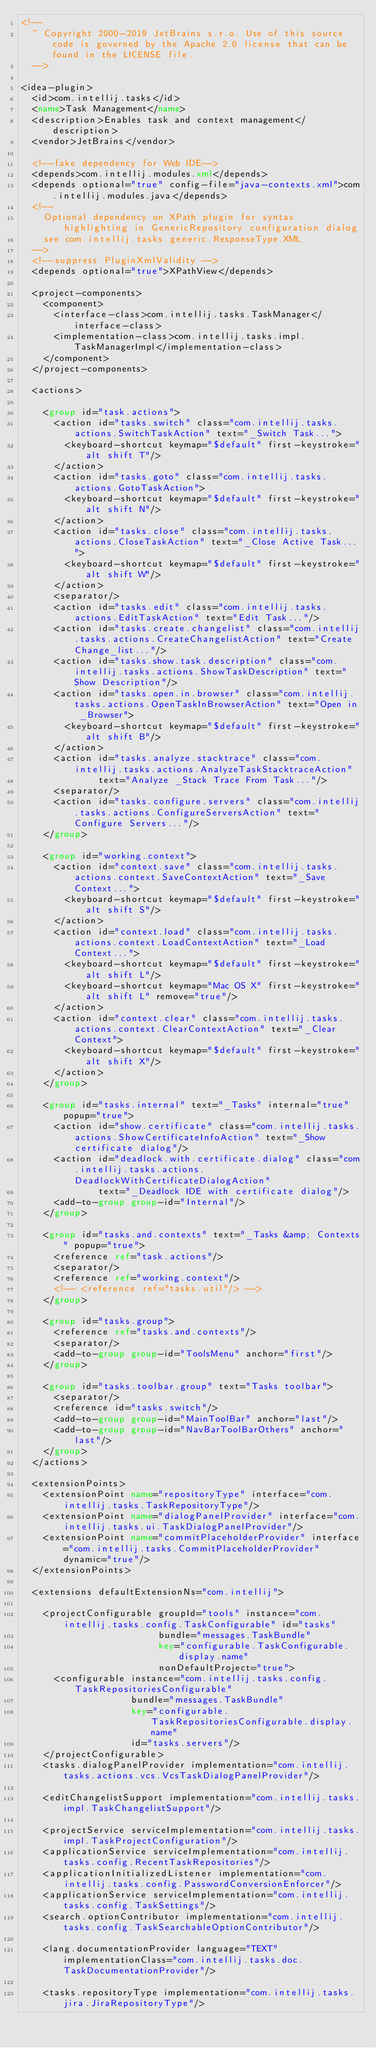Convert code to text. <code><loc_0><loc_0><loc_500><loc_500><_XML_><!--
  ~ Copyright 2000-2019 JetBrains s.r.o. Use of this source code is governed by the Apache 2.0 license that can be found in the LICENSE file.
  -->

<idea-plugin>
  <id>com.intellij.tasks</id>
  <name>Task Management</name>
  <description>Enables task and context management</description>
  <vendor>JetBrains</vendor>

  <!--fake dependency for Web IDE-->
  <depends>com.intellij.modules.xml</depends>
  <depends optional="true" config-file="java-contexts.xml">com.intellij.modules.java</depends>
  <!--
    Optional dependency on XPath plugin for syntax highlighting in GenericRepository configuration dialog
    see com.intellij.tasks.generic.ResponseType.XML
  -->
  <!--suppress PluginXmlValidity -->
  <depends optional="true">XPathView</depends>

  <project-components>
    <component>
      <interface-class>com.intellij.tasks.TaskManager</interface-class>
      <implementation-class>com.intellij.tasks.impl.TaskManagerImpl</implementation-class>
    </component>
  </project-components>

  <actions>

    <group id="task.actions">
      <action id="tasks.switch" class="com.intellij.tasks.actions.SwitchTaskAction" text="_Switch Task...">
        <keyboard-shortcut keymap="$default" first-keystroke="alt shift T"/>
      </action>
      <action id="tasks.goto" class="com.intellij.tasks.actions.GotoTaskAction">
        <keyboard-shortcut keymap="$default" first-keystroke="alt shift N"/>
      </action>
      <action id="tasks.close" class="com.intellij.tasks.actions.CloseTaskAction" text="_Close Active Task...">
        <keyboard-shortcut keymap="$default" first-keystroke="alt shift W"/>
      </action>
      <separator/>
      <action id="tasks.edit" class="com.intellij.tasks.actions.EditTaskAction" text="Edit Task..."/>
      <action id="tasks.create.changelist" class="com.intellij.tasks.actions.CreateChangelistAction" text="Create Change_list..."/>
      <action id="tasks.show.task.description" class="com.intellij.tasks.actions.ShowTaskDescription" text="Show Description"/>
      <action id="tasks.open.in.browser" class="com.intellij.tasks.actions.OpenTaskInBrowserAction" text="Open in _Browser">
        <keyboard-shortcut keymap="$default" first-keystroke="alt shift B"/>
      </action>
      <action id="tasks.analyze.stacktrace" class="com.intellij.tasks.actions.AnalyzeTaskStacktraceAction"
              text="Analyze _Stack Trace From Task..."/>
      <separator/>
      <action id="tasks.configure.servers" class="com.intellij.tasks.actions.ConfigureServersAction" text="Configure Servers..."/>
    </group>

    <group id="working.context">
      <action id="context.save" class="com.intellij.tasks.actions.context.SaveContextAction" text="_Save Context...">
        <keyboard-shortcut keymap="$default" first-keystroke="alt shift S"/>
      </action>
      <action id="context.load" class="com.intellij.tasks.actions.context.LoadContextAction" text="_Load Context...">
        <keyboard-shortcut keymap="$default" first-keystroke="alt shift L"/>
        <keyboard-shortcut keymap="Mac OS X" first-keystroke="alt shift L" remove="true"/>
      </action>
      <action id="context.clear" class="com.intellij.tasks.actions.context.ClearContextAction" text="_Clear Context">
        <keyboard-shortcut keymap="$default" first-keystroke="alt shift X"/>
      </action>
    </group>

    <group id="tasks.internal" text="_Tasks" internal="true" popup="true">
      <action id="show.certificate" class="com.intellij.tasks.actions.ShowCertificateInfoAction" text="_Show certificate dialog"/>
      <action id="deadlock.with.certificate.dialog" class="com.intellij.tasks.actions.DeadlockWithCertificateDialogAction"
              text="_Deadlock IDE with certificate dialog"/>
      <add-to-group group-id="Internal"/>
    </group>

    <group id="tasks.and.contexts" text="_Tasks &amp; Contexts" popup="true">
      <reference ref="task.actions"/>
      <separator/>
      <reference ref="working.context"/>
      <!-- <reference ref="tasks.util"/> -->
    </group>

    <group id="tasks.group">
      <reference ref="tasks.and.contexts"/>
      <separator/>
      <add-to-group group-id="ToolsMenu" anchor="first"/>
    </group>

    <group id="tasks.toolbar.group" text="Tasks toolbar">
      <separator/>
      <reference id="tasks.switch"/>
      <add-to-group group-id="MainToolBar" anchor="last"/>
      <add-to-group group-id="NavBarToolBarOthers" anchor="last"/>
    </group>
  </actions>

  <extensionPoints>
    <extensionPoint name="repositoryType" interface="com.intellij.tasks.TaskRepositoryType"/>
    <extensionPoint name="dialogPanelProvider" interface="com.intellij.tasks.ui.TaskDialogPanelProvider"/>
    <extensionPoint name="commitPlaceholderProvider" interface="com.intellij.tasks.CommitPlaceholderProvider" dynamic="true"/>
  </extensionPoints>

  <extensions defaultExtensionNs="com.intellij">

    <projectConfigurable groupId="tools" instance="com.intellij.tasks.config.TaskConfigurable" id="tasks"
                         bundle="messages.TaskBundle"
                         key="configurable.TaskConfigurable.display.name"
                         nonDefaultProject="true">
      <configurable instance="com.intellij.tasks.config.TaskRepositoriesConfigurable"
                    bundle="messages.TaskBundle"
                    key="configurable.TaskRepositoriesConfigurable.display.name"
                    id="tasks.servers"/>
    </projectConfigurable>
    <tasks.dialogPanelProvider implementation="com.intellij.tasks.actions.vcs.VcsTaskDialogPanelProvider"/>

    <editChangelistSupport implementation="com.intellij.tasks.impl.TaskChangelistSupport"/>

    <projectService serviceImplementation="com.intellij.tasks.impl.TaskProjectConfiguration"/>
    <applicationService serviceImplementation="com.intellij.tasks.config.RecentTaskRepositories"/>
    <applicationInitializedListener implementation="com.intellij.tasks.config.PasswordConversionEnforcer"/>
    <applicationService serviceImplementation="com.intellij.tasks.config.TaskSettings"/>
    <search.optionContributor implementation="com.intellij.tasks.config.TaskSearchableOptionContributor"/>

    <lang.documentationProvider language="TEXT" implementationClass="com.intellij.tasks.doc.TaskDocumentationProvider"/>

    <tasks.repositoryType implementation="com.intellij.tasks.jira.JiraRepositoryType"/></code> 